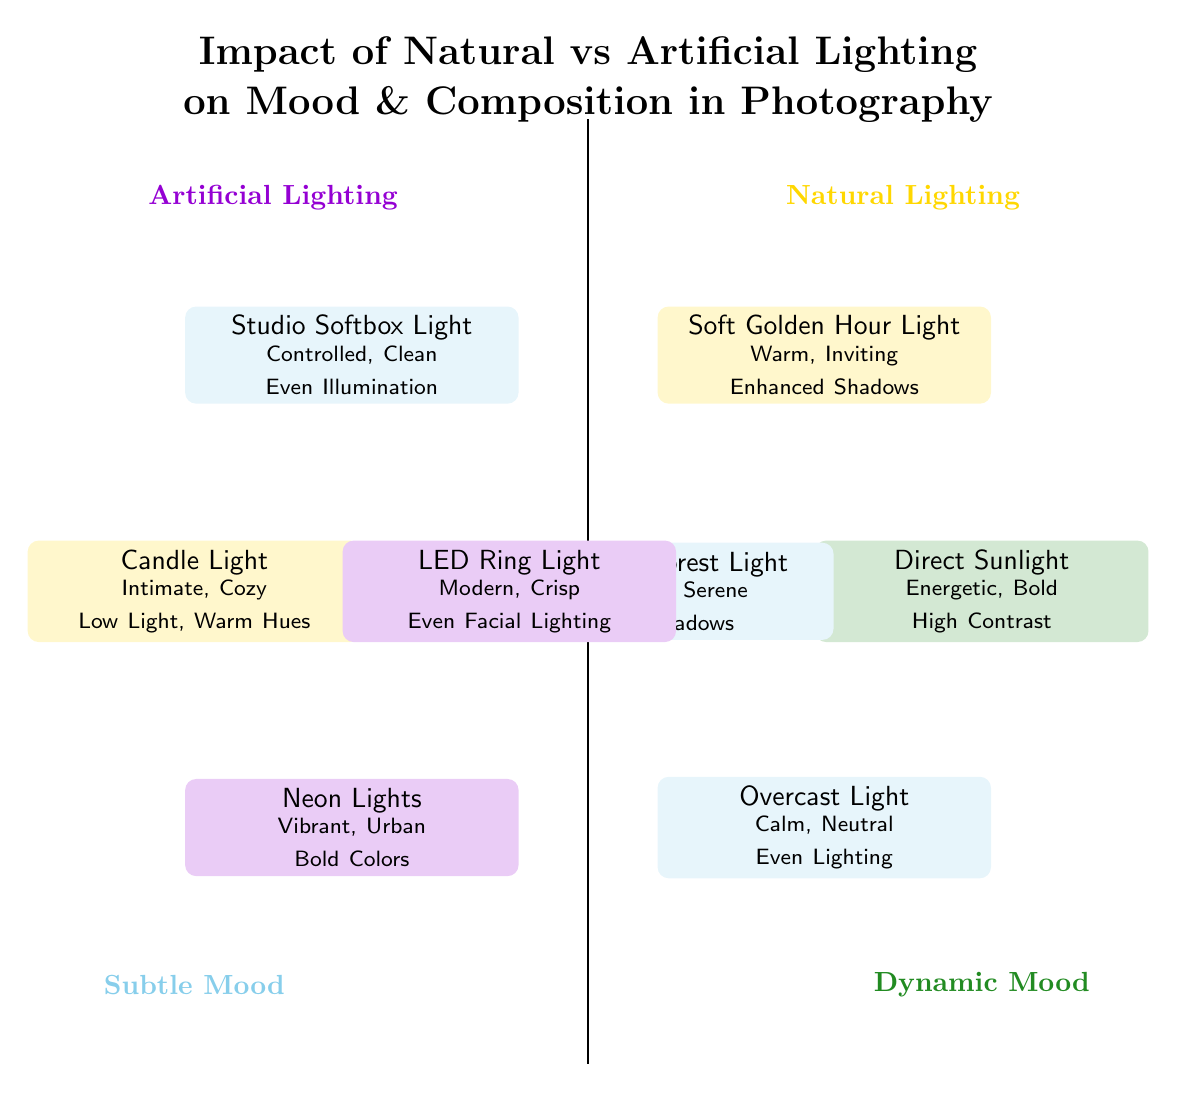What is the mood associated with Direct Sunlight? According to the diagram, the mood associated with Direct Sunlight is listed as "Energetic, Harsh, Bold." This can be found in the corresponding node within the Natural Lighting quadrant.
Answer: Energetic, Harsh, Bold How many different lighting types are represented in the diagram? The diagram depicts four types of Natural Lighting and four types of Artificial Lighting. By adding these together, there are a total of eight different lighting types represented.
Answer: 8 Which lighting type has a "Cozy" mood? The mood "Cozy" is specifically associated with the Candle Light in the Artificial Lighting quadrant. This can be identified by examining the mood description in that node.
Answer: Candle Light What composition is associated with Studio Softbox Light? The composition related to Studio Softbox Light is described as "Soft, Even Illumination." This information can be found in the corresponding node in the Artificial Lighting section.
Answer: Soft, Even Illumination Which type of lighting delivers a "Vibrant" mood? The type of lighting that delivers a "Vibrant" mood is the Neon Lights found in the Artificial Lighting quadrant. The mood description for this lighting type contains the word "Vibrant."
Answer: Neon Lights Which quadrant represents "Calm, Neutral" mood lighting? The "Calm, Neutral" mood lighting is represented by the Overcast Light, which is found in the lower part of the Natural Lighting quadrant. This is derived from the node's description within that quadrant.
Answer: Natural Lighting From which category does "LED Ring Light" belong? The "LED Ring Light" belongs to the Artificial Lighting category, as indicated by its position in the quadrant that specifically contains various types of artificial lighting options.
Answer: Artificial Lighting Which lighting type features "Bold Colors"? The lighting type that features "Bold Colors" is Neon Lights, located in the Artificial Lighting section. This is clear from the specific composition description under that node.
Answer: Neon Lights What is the example scene for the Diffused Forest Light? The example scene provided for the Diffused Forest Light is "Foggy Morning Paths in Redwood Forest." This is stated in the node for Diffused Forest Light within the Natural Lighting quadrant.
Answer: Foggy Morning Paths in Redwood Forest 